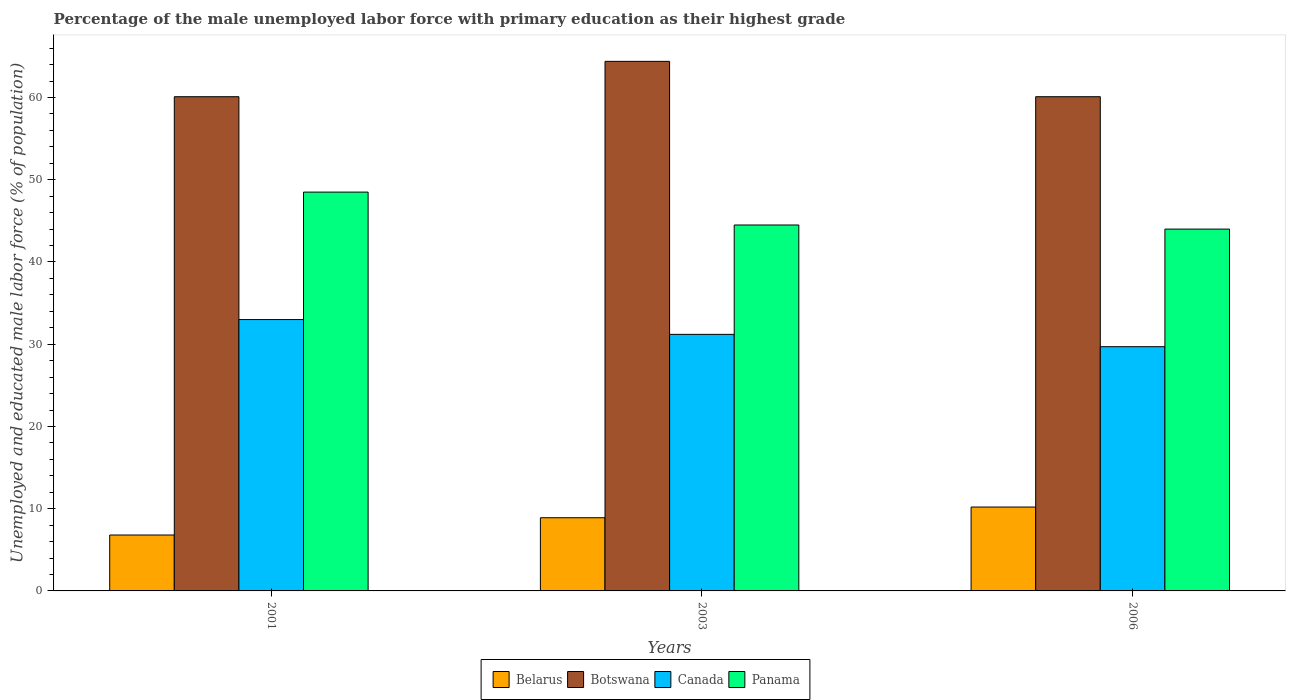Are the number of bars on each tick of the X-axis equal?
Your answer should be compact. Yes. How many bars are there on the 3rd tick from the right?
Ensure brevity in your answer.  4. What is the label of the 1st group of bars from the left?
Ensure brevity in your answer.  2001. In how many cases, is the number of bars for a given year not equal to the number of legend labels?
Your response must be concise. 0. What is the percentage of the unemployed male labor force with primary education in Botswana in 2006?
Ensure brevity in your answer.  60.1. Across all years, what is the maximum percentage of the unemployed male labor force with primary education in Botswana?
Your response must be concise. 64.4. Across all years, what is the minimum percentage of the unemployed male labor force with primary education in Canada?
Make the answer very short. 29.7. What is the total percentage of the unemployed male labor force with primary education in Canada in the graph?
Offer a very short reply. 93.9. What is the difference between the percentage of the unemployed male labor force with primary education in Canada in 2001 and that in 2003?
Offer a very short reply. 1.8. What is the difference between the percentage of the unemployed male labor force with primary education in Panama in 2003 and the percentage of the unemployed male labor force with primary education in Botswana in 2006?
Your answer should be compact. -15.6. What is the average percentage of the unemployed male labor force with primary education in Canada per year?
Provide a succinct answer. 31.3. In the year 2006, what is the difference between the percentage of the unemployed male labor force with primary education in Panama and percentage of the unemployed male labor force with primary education in Canada?
Your answer should be compact. 14.3. In how many years, is the percentage of the unemployed male labor force with primary education in Canada greater than 40 %?
Provide a succinct answer. 0. What is the ratio of the percentage of the unemployed male labor force with primary education in Canada in 2001 to that in 2006?
Your answer should be compact. 1.11. Is the difference between the percentage of the unemployed male labor force with primary education in Panama in 2001 and 2006 greater than the difference between the percentage of the unemployed male labor force with primary education in Canada in 2001 and 2006?
Provide a succinct answer. Yes. In how many years, is the percentage of the unemployed male labor force with primary education in Canada greater than the average percentage of the unemployed male labor force with primary education in Canada taken over all years?
Make the answer very short. 1. Is it the case that in every year, the sum of the percentage of the unemployed male labor force with primary education in Botswana and percentage of the unemployed male labor force with primary education in Belarus is greater than the sum of percentage of the unemployed male labor force with primary education in Canada and percentage of the unemployed male labor force with primary education in Panama?
Ensure brevity in your answer.  Yes. What does the 1st bar from the left in 2006 represents?
Make the answer very short. Belarus. What does the 4th bar from the right in 2006 represents?
Your answer should be compact. Belarus. How many bars are there?
Your answer should be very brief. 12. How many years are there in the graph?
Ensure brevity in your answer.  3. Are the values on the major ticks of Y-axis written in scientific E-notation?
Ensure brevity in your answer.  No. Does the graph contain any zero values?
Offer a very short reply. No. Does the graph contain grids?
Give a very brief answer. No. Where does the legend appear in the graph?
Provide a succinct answer. Bottom center. How many legend labels are there?
Your answer should be very brief. 4. What is the title of the graph?
Give a very brief answer. Percentage of the male unemployed labor force with primary education as their highest grade. What is the label or title of the Y-axis?
Offer a terse response. Unemployed and educated male labor force (% of population). What is the Unemployed and educated male labor force (% of population) of Belarus in 2001?
Your response must be concise. 6.8. What is the Unemployed and educated male labor force (% of population) in Botswana in 2001?
Provide a succinct answer. 60.1. What is the Unemployed and educated male labor force (% of population) in Panama in 2001?
Keep it short and to the point. 48.5. What is the Unemployed and educated male labor force (% of population) of Belarus in 2003?
Offer a terse response. 8.9. What is the Unemployed and educated male labor force (% of population) of Botswana in 2003?
Give a very brief answer. 64.4. What is the Unemployed and educated male labor force (% of population) in Canada in 2003?
Ensure brevity in your answer.  31.2. What is the Unemployed and educated male labor force (% of population) in Panama in 2003?
Offer a very short reply. 44.5. What is the Unemployed and educated male labor force (% of population) in Belarus in 2006?
Provide a succinct answer. 10.2. What is the Unemployed and educated male labor force (% of population) in Botswana in 2006?
Your answer should be compact. 60.1. What is the Unemployed and educated male labor force (% of population) of Canada in 2006?
Ensure brevity in your answer.  29.7. What is the Unemployed and educated male labor force (% of population) of Panama in 2006?
Your response must be concise. 44. Across all years, what is the maximum Unemployed and educated male labor force (% of population) in Belarus?
Keep it short and to the point. 10.2. Across all years, what is the maximum Unemployed and educated male labor force (% of population) in Botswana?
Offer a terse response. 64.4. Across all years, what is the maximum Unemployed and educated male labor force (% of population) of Canada?
Your response must be concise. 33. Across all years, what is the maximum Unemployed and educated male labor force (% of population) in Panama?
Offer a very short reply. 48.5. Across all years, what is the minimum Unemployed and educated male labor force (% of population) in Belarus?
Keep it short and to the point. 6.8. Across all years, what is the minimum Unemployed and educated male labor force (% of population) of Botswana?
Your answer should be compact. 60.1. Across all years, what is the minimum Unemployed and educated male labor force (% of population) in Canada?
Make the answer very short. 29.7. What is the total Unemployed and educated male labor force (% of population) of Belarus in the graph?
Provide a succinct answer. 25.9. What is the total Unemployed and educated male labor force (% of population) in Botswana in the graph?
Your response must be concise. 184.6. What is the total Unemployed and educated male labor force (% of population) in Canada in the graph?
Provide a succinct answer. 93.9. What is the total Unemployed and educated male labor force (% of population) in Panama in the graph?
Provide a succinct answer. 137. What is the difference between the Unemployed and educated male labor force (% of population) in Belarus in 2001 and that in 2006?
Offer a very short reply. -3.4. What is the difference between the Unemployed and educated male labor force (% of population) in Belarus in 2003 and that in 2006?
Provide a succinct answer. -1.3. What is the difference between the Unemployed and educated male labor force (% of population) of Botswana in 2003 and that in 2006?
Give a very brief answer. 4.3. What is the difference between the Unemployed and educated male labor force (% of population) of Panama in 2003 and that in 2006?
Provide a short and direct response. 0.5. What is the difference between the Unemployed and educated male labor force (% of population) in Belarus in 2001 and the Unemployed and educated male labor force (% of population) in Botswana in 2003?
Your response must be concise. -57.6. What is the difference between the Unemployed and educated male labor force (% of population) in Belarus in 2001 and the Unemployed and educated male labor force (% of population) in Canada in 2003?
Ensure brevity in your answer.  -24.4. What is the difference between the Unemployed and educated male labor force (% of population) in Belarus in 2001 and the Unemployed and educated male labor force (% of population) in Panama in 2003?
Provide a short and direct response. -37.7. What is the difference between the Unemployed and educated male labor force (% of population) in Botswana in 2001 and the Unemployed and educated male labor force (% of population) in Canada in 2003?
Give a very brief answer. 28.9. What is the difference between the Unemployed and educated male labor force (% of population) of Botswana in 2001 and the Unemployed and educated male labor force (% of population) of Panama in 2003?
Your response must be concise. 15.6. What is the difference between the Unemployed and educated male labor force (% of population) of Canada in 2001 and the Unemployed and educated male labor force (% of population) of Panama in 2003?
Your answer should be very brief. -11.5. What is the difference between the Unemployed and educated male labor force (% of population) in Belarus in 2001 and the Unemployed and educated male labor force (% of population) in Botswana in 2006?
Your answer should be compact. -53.3. What is the difference between the Unemployed and educated male labor force (% of population) in Belarus in 2001 and the Unemployed and educated male labor force (% of population) in Canada in 2006?
Offer a terse response. -22.9. What is the difference between the Unemployed and educated male labor force (% of population) in Belarus in 2001 and the Unemployed and educated male labor force (% of population) in Panama in 2006?
Your response must be concise. -37.2. What is the difference between the Unemployed and educated male labor force (% of population) in Botswana in 2001 and the Unemployed and educated male labor force (% of population) in Canada in 2006?
Your answer should be very brief. 30.4. What is the difference between the Unemployed and educated male labor force (% of population) of Botswana in 2001 and the Unemployed and educated male labor force (% of population) of Panama in 2006?
Offer a terse response. 16.1. What is the difference between the Unemployed and educated male labor force (% of population) of Canada in 2001 and the Unemployed and educated male labor force (% of population) of Panama in 2006?
Ensure brevity in your answer.  -11. What is the difference between the Unemployed and educated male labor force (% of population) in Belarus in 2003 and the Unemployed and educated male labor force (% of population) in Botswana in 2006?
Make the answer very short. -51.2. What is the difference between the Unemployed and educated male labor force (% of population) in Belarus in 2003 and the Unemployed and educated male labor force (% of population) in Canada in 2006?
Offer a terse response. -20.8. What is the difference between the Unemployed and educated male labor force (% of population) of Belarus in 2003 and the Unemployed and educated male labor force (% of population) of Panama in 2006?
Provide a succinct answer. -35.1. What is the difference between the Unemployed and educated male labor force (% of population) of Botswana in 2003 and the Unemployed and educated male labor force (% of population) of Canada in 2006?
Give a very brief answer. 34.7. What is the difference between the Unemployed and educated male labor force (% of population) of Botswana in 2003 and the Unemployed and educated male labor force (% of population) of Panama in 2006?
Offer a very short reply. 20.4. What is the difference between the Unemployed and educated male labor force (% of population) in Canada in 2003 and the Unemployed and educated male labor force (% of population) in Panama in 2006?
Offer a very short reply. -12.8. What is the average Unemployed and educated male labor force (% of population) in Belarus per year?
Keep it short and to the point. 8.63. What is the average Unemployed and educated male labor force (% of population) in Botswana per year?
Offer a very short reply. 61.53. What is the average Unemployed and educated male labor force (% of population) of Canada per year?
Your answer should be very brief. 31.3. What is the average Unemployed and educated male labor force (% of population) in Panama per year?
Give a very brief answer. 45.67. In the year 2001, what is the difference between the Unemployed and educated male labor force (% of population) in Belarus and Unemployed and educated male labor force (% of population) in Botswana?
Keep it short and to the point. -53.3. In the year 2001, what is the difference between the Unemployed and educated male labor force (% of population) in Belarus and Unemployed and educated male labor force (% of population) in Canada?
Your answer should be very brief. -26.2. In the year 2001, what is the difference between the Unemployed and educated male labor force (% of population) in Belarus and Unemployed and educated male labor force (% of population) in Panama?
Offer a very short reply. -41.7. In the year 2001, what is the difference between the Unemployed and educated male labor force (% of population) of Botswana and Unemployed and educated male labor force (% of population) of Canada?
Give a very brief answer. 27.1. In the year 2001, what is the difference between the Unemployed and educated male labor force (% of population) of Canada and Unemployed and educated male labor force (% of population) of Panama?
Your answer should be compact. -15.5. In the year 2003, what is the difference between the Unemployed and educated male labor force (% of population) in Belarus and Unemployed and educated male labor force (% of population) in Botswana?
Keep it short and to the point. -55.5. In the year 2003, what is the difference between the Unemployed and educated male labor force (% of population) of Belarus and Unemployed and educated male labor force (% of population) of Canada?
Keep it short and to the point. -22.3. In the year 2003, what is the difference between the Unemployed and educated male labor force (% of population) of Belarus and Unemployed and educated male labor force (% of population) of Panama?
Provide a succinct answer. -35.6. In the year 2003, what is the difference between the Unemployed and educated male labor force (% of population) of Botswana and Unemployed and educated male labor force (% of population) of Canada?
Give a very brief answer. 33.2. In the year 2003, what is the difference between the Unemployed and educated male labor force (% of population) in Botswana and Unemployed and educated male labor force (% of population) in Panama?
Your response must be concise. 19.9. In the year 2006, what is the difference between the Unemployed and educated male labor force (% of population) of Belarus and Unemployed and educated male labor force (% of population) of Botswana?
Make the answer very short. -49.9. In the year 2006, what is the difference between the Unemployed and educated male labor force (% of population) in Belarus and Unemployed and educated male labor force (% of population) in Canada?
Provide a succinct answer. -19.5. In the year 2006, what is the difference between the Unemployed and educated male labor force (% of population) of Belarus and Unemployed and educated male labor force (% of population) of Panama?
Offer a very short reply. -33.8. In the year 2006, what is the difference between the Unemployed and educated male labor force (% of population) in Botswana and Unemployed and educated male labor force (% of population) in Canada?
Offer a terse response. 30.4. In the year 2006, what is the difference between the Unemployed and educated male labor force (% of population) of Canada and Unemployed and educated male labor force (% of population) of Panama?
Give a very brief answer. -14.3. What is the ratio of the Unemployed and educated male labor force (% of population) in Belarus in 2001 to that in 2003?
Your answer should be compact. 0.76. What is the ratio of the Unemployed and educated male labor force (% of population) of Botswana in 2001 to that in 2003?
Ensure brevity in your answer.  0.93. What is the ratio of the Unemployed and educated male labor force (% of population) in Canada in 2001 to that in 2003?
Make the answer very short. 1.06. What is the ratio of the Unemployed and educated male labor force (% of population) in Panama in 2001 to that in 2003?
Your answer should be compact. 1.09. What is the ratio of the Unemployed and educated male labor force (% of population) in Panama in 2001 to that in 2006?
Provide a short and direct response. 1.1. What is the ratio of the Unemployed and educated male labor force (% of population) in Belarus in 2003 to that in 2006?
Your answer should be very brief. 0.87. What is the ratio of the Unemployed and educated male labor force (% of population) in Botswana in 2003 to that in 2006?
Offer a terse response. 1.07. What is the ratio of the Unemployed and educated male labor force (% of population) of Canada in 2003 to that in 2006?
Give a very brief answer. 1.05. What is the ratio of the Unemployed and educated male labor force (% of population) of Panama in 2003 to that in 2006?
Make the answer very short. 1.01. What is the difference between the highest and the second highest Unemployed and educated male labor force (% of population) of Botswana?
Your answer should be compact. 4.3. What is the difference between the highest and the second highest Unemployed and educated male labor force (% of population) of Canada?
Provide a succinct answer. 1.8. What is the difference between the highest and the second highest Unemployed and educated male labor force (% of population) in Panama?
Offer a terse response. 4. What is the difference between the highest and the lowest Unemployed and educated male labor force (% of population) of Botswana?
Your response must be concise. 4.3. 